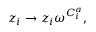<formula> <loc_0><loc_0><loc_500><loc_500>z _ { i } \rightarrow z _ { i } \omega ^ { C _ { i } ^ { a } } ,</formula> 